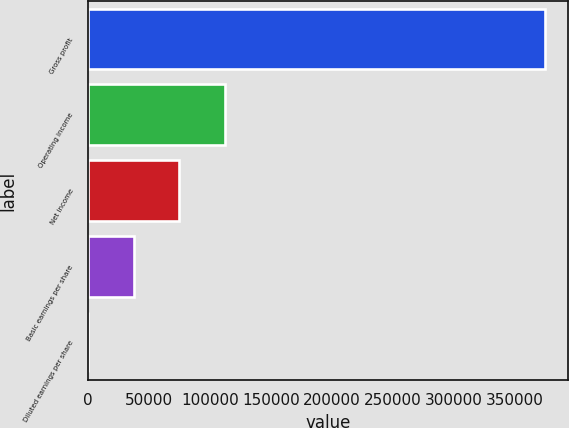<chart> <loc_0><loc_0><loc_500><loc_500><bar_chart><fcel>Gross profit<fcel>Operating income<fcel>Net income<fcel>Basic earnings per share<fcel>Diluted earnings per share<nl><fcel>374584<fcel>112375<fcel>74916.8<fcel>37458.4<fcel>0.06<nl></chart> 